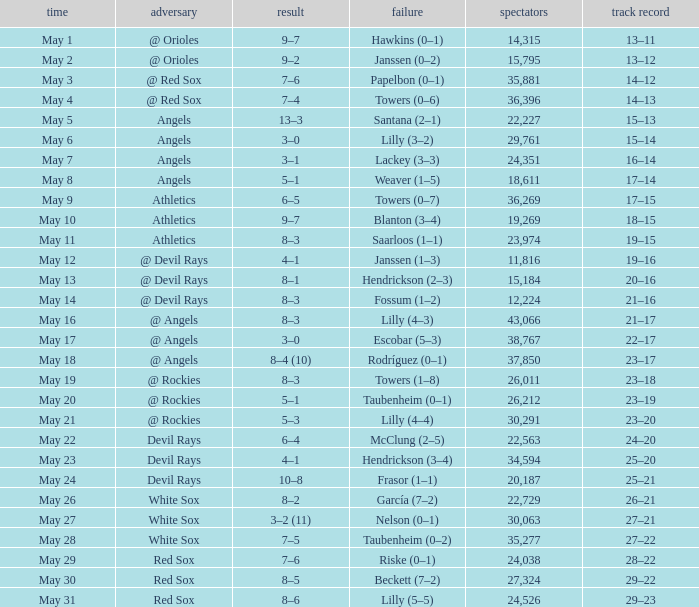When the team had their record of 16–14, what was the total attendance? 1.0. Could you help me parse every detail presented in this table? {'header': ['time', 'adversary', 'result', 'failure', 'spectators', 'track record'], 'rows': [['May 1', '@ Orioles', '9–7', 'Hawkins (0–1)', '14,315', '13–11'], ['May 2', '@ Orioles', '9–2', 'Janssen (0–2)', '15,795', '13–12'], ['May 3', '@ Red Sox', '7–6', 'Papelbon (0–1)', '35,881', '14–12'], ['May 4', '@ Red Sox', '7–4', 'Towers (0–6)', '36,396', '14–13'], ['May 5', 'Angels', '13–3', 'Santana (2–1)', '22,227', '15–13'], ['May 6', 'Angels', '3–0', 'Lilly (3–2)', '29,761', '15–14'], ['May 7', 'Angels', '3–1', 'Lackey (3–3)', '24,351', '16–14'], ['May 8', 'Angels', '5–1', 'Weaver (1–5)', '18,611', '17–14'], ['May 9', 'Athletics', '6–5', 'Towers (0–7)', '36,269', '17–15'], ['May 10', 'Athletics', '9–7', 'Blanton (3–4)', '19,269', '18–15'], ['May 11', 'Athletics', '8–3', 'Saarloos (1–1)', '23,974', '19–15'], ['May 12', '@ Devil Rays', '4–1', 'Janssen (1–3)', '11,816', '19–16'], ['May 13', '@ Devil Rays', '8–1', 'Hendrickson (2–3)', '15,184', '20–16'], ['May 14', '@ Devil Rays', '8–3', 'Fossum (1–2)', '12,224', '21–16'], ['May 16', '@ Angels', '8–3', 'Lilly (4–3)', '43,066', '21–17'], ['May 17', '@ Angels', '3–0', 'Escobar (5–3)', '38,767', '22–17'], ['May 18', '@ Angels', '8–4 (10)', 'Rodríguez (0–1)', '37,850', '23–17'], ['May 19', '@ Rockies', '8–3', 'Towers (1–8)', '26,011', '23–18'], ['May 20', '@ Rockies', '5–1', 'Taubenheim (0–1)', '26,212', '23–19'], ['May 21', '@ Rockies', '5–3', 'Lilly (4–4)', '30,291', '23–20'], ['May 22', 'Devil Rays', '6–4', 'McClung (2–5)', '22,563', '24–20'], ['May 23', 'Devil Rays', '4–1', 'Hendrickson (3–4)', '34,594', '25–20'], ['May 24', 'Devil Rays', '10–8', 'Frasor (1–1)', '20,187', '25–21'], ['May 26', 'White Sox', '8–2', 'García (7–2)', '22,729', '26–21'], ['May 27', 'White Sox', '3–2 (11)', 'Nelson (0–1)', '30,063', '27–21'], ['May 28', 'White Sox', '7–5', 'Taubenheim (0–2)', '35,277', '27–22'], ['May 29', 'Red Sox', '7–6', 'Riske (0–1)', '24,038', '28–22'], ['May 30', 'Red Sox', '8–5', 'Beckett (7–2)', '27,324', '29–22'], ['May 31', 'Red Sox', '8–6', 'Lilly (5–5)', '24,526', '29–23']]} 